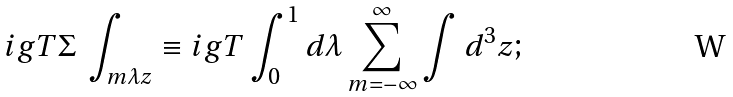Convert formula to latex. <formula><loc_0><loc_0><loc_500><loc_500>i g T \Sigma \, \int _ { m \lambda z } \equiv i g T \int _ { 0 } ^ { 1 } d \lambda \sum _ { m = - \infty } ^ { \infty } \int d ^ { 3 } z ;</formula> 